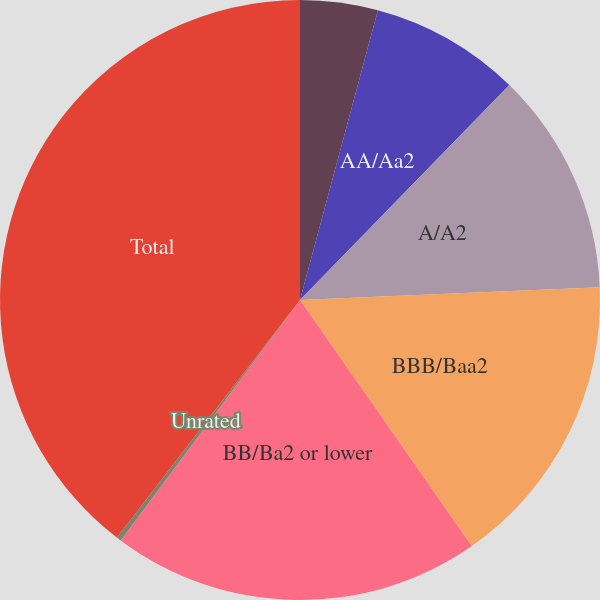Convert chart to OTSL. <chart><loc_0><loc_0><loc_500><loc_500><pie_chart><fcel>AAA/Aaa<fcel>AA/Aa2<fcel>A/A2<fcel>BBB/Baa2<fcel>BB/Ba2 or lower<fcel>Unrated<fcel>Total<nl><fcel>4.18%<fcel>8.11%<fcel>12.04%<fcel>15.97%<fcel>19.9%<fcel>0.25%<fcel>39.55%<nl></chart> 